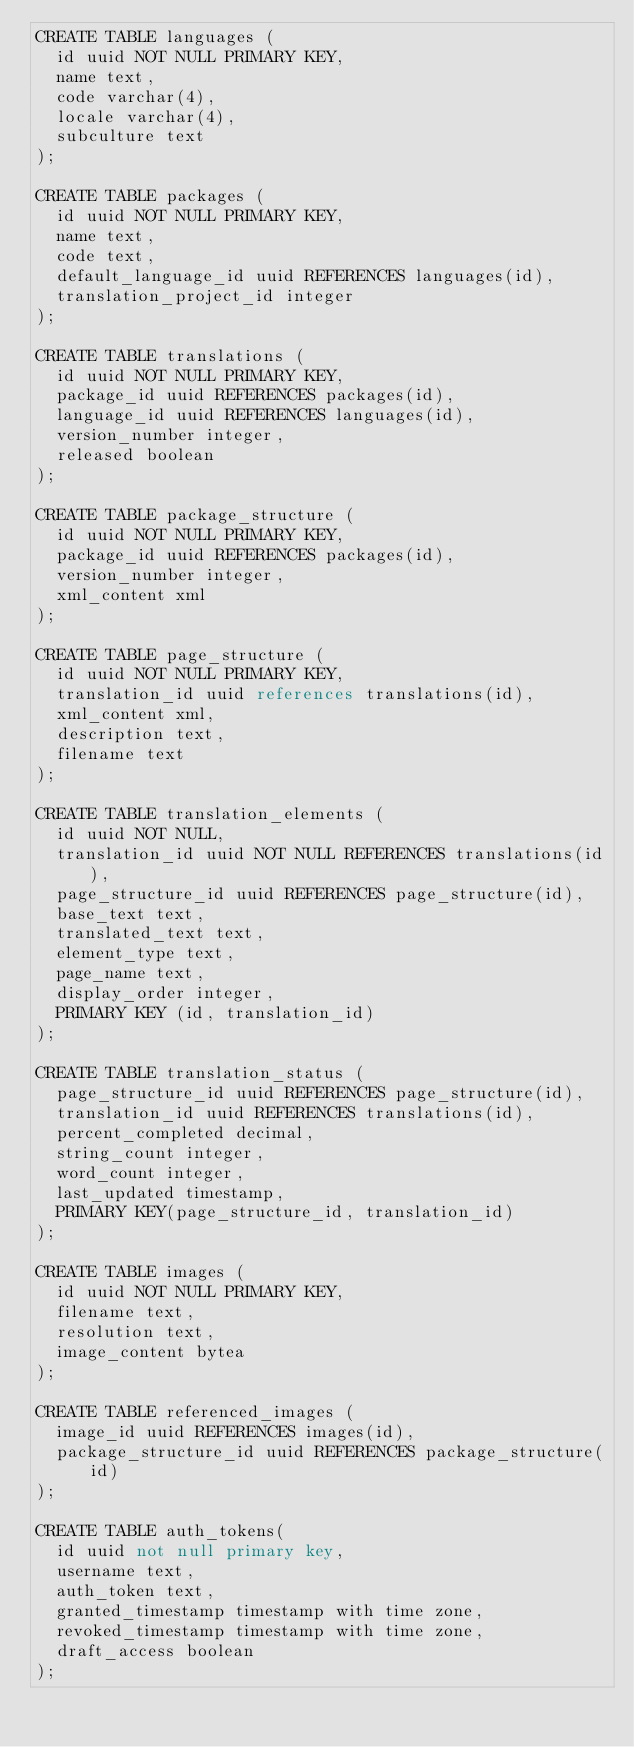<code> <loc_0><loc_0><loc_500><loc_500><_SQL_>CREATE TABLE languages (
  id uuid NOT NULL PRIMARY KEY,
  name text,
  code varchar(4),
  locale varchar(4),
  subculture text
);

CREATE TABLE packages (
  id uuid NOT NULL PRIMARY KEY,
  name text,
  code text,
  default_language_id uuid REFERENCES languages(id),
  translation_project_id integer
);

CREATE TABLE translations (
  id uuid NOT NULL PRIMARY KEY,
  package_id uuid REFERENCES packages(id),
  language_id uuid REFERENCES languages(id),
  version_number integer,
  released boolean
);

CREATE TABLE package_structure (
  id uuid NOT NULL PRIMARY KEY,
  package_id uuid REFERENCES packages(id),
  version_number integer,
  xml_content xml
);

CREATE TABLE page_structure (
  id uuid NOT NULL PRIMARY KEY,
  translation_id uuid references translations(id),
  xml_content xml,
  description text,
  filename text
);

CREATE TABLE translation_elements (
  id uuid NOT NULL,
  translation_id uuid NOT NULL REFERENCES translations(id),
  page_structure_id uuid REFERENCES page_structure(id),
  base_text text,
  translated_text text,
  element_type text,
  page_name text,
  display_order integer,
  PRIMARY KEY (id, translation_id)
);

CREATE TABLE translation_status (
  page_structure_id uuid REFERENCES page_structure(id),
  translation_id uuid REFERENCES translations(id),
  percent_completed decimal,
  string_count integer,
  word_count integer,
  last_updated timestamp,
  PRIMARY KEY(page_structure_id, translation_id)
);

CREATE TABLE images (
  id uuid NOT NULL PRIMARY KEY,
  filename text,
  resolution text,
  image_content bytea
);

CREATE TABLE referenced_images (
  image_id uuid REFERENCES images(id),
  package_structure_id uuid REFERENCES package_structure(id)
);

CREATE TABLE auth_tokens(
  id uuid not null primary key,
  username text,
  auth_token text,
  granted_timestamp timestamp with time zone,
  revoked_timestamp timestamp with time zone,
  draft_access boolean
);
</code> 